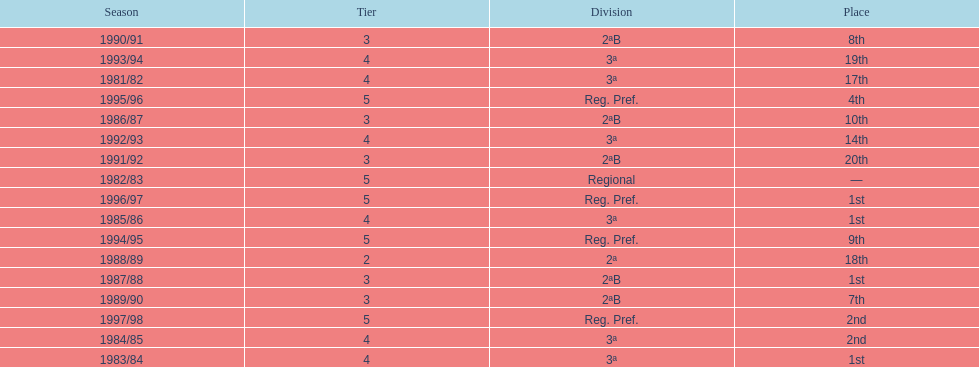How many seasons are shown in this chart? 17. 